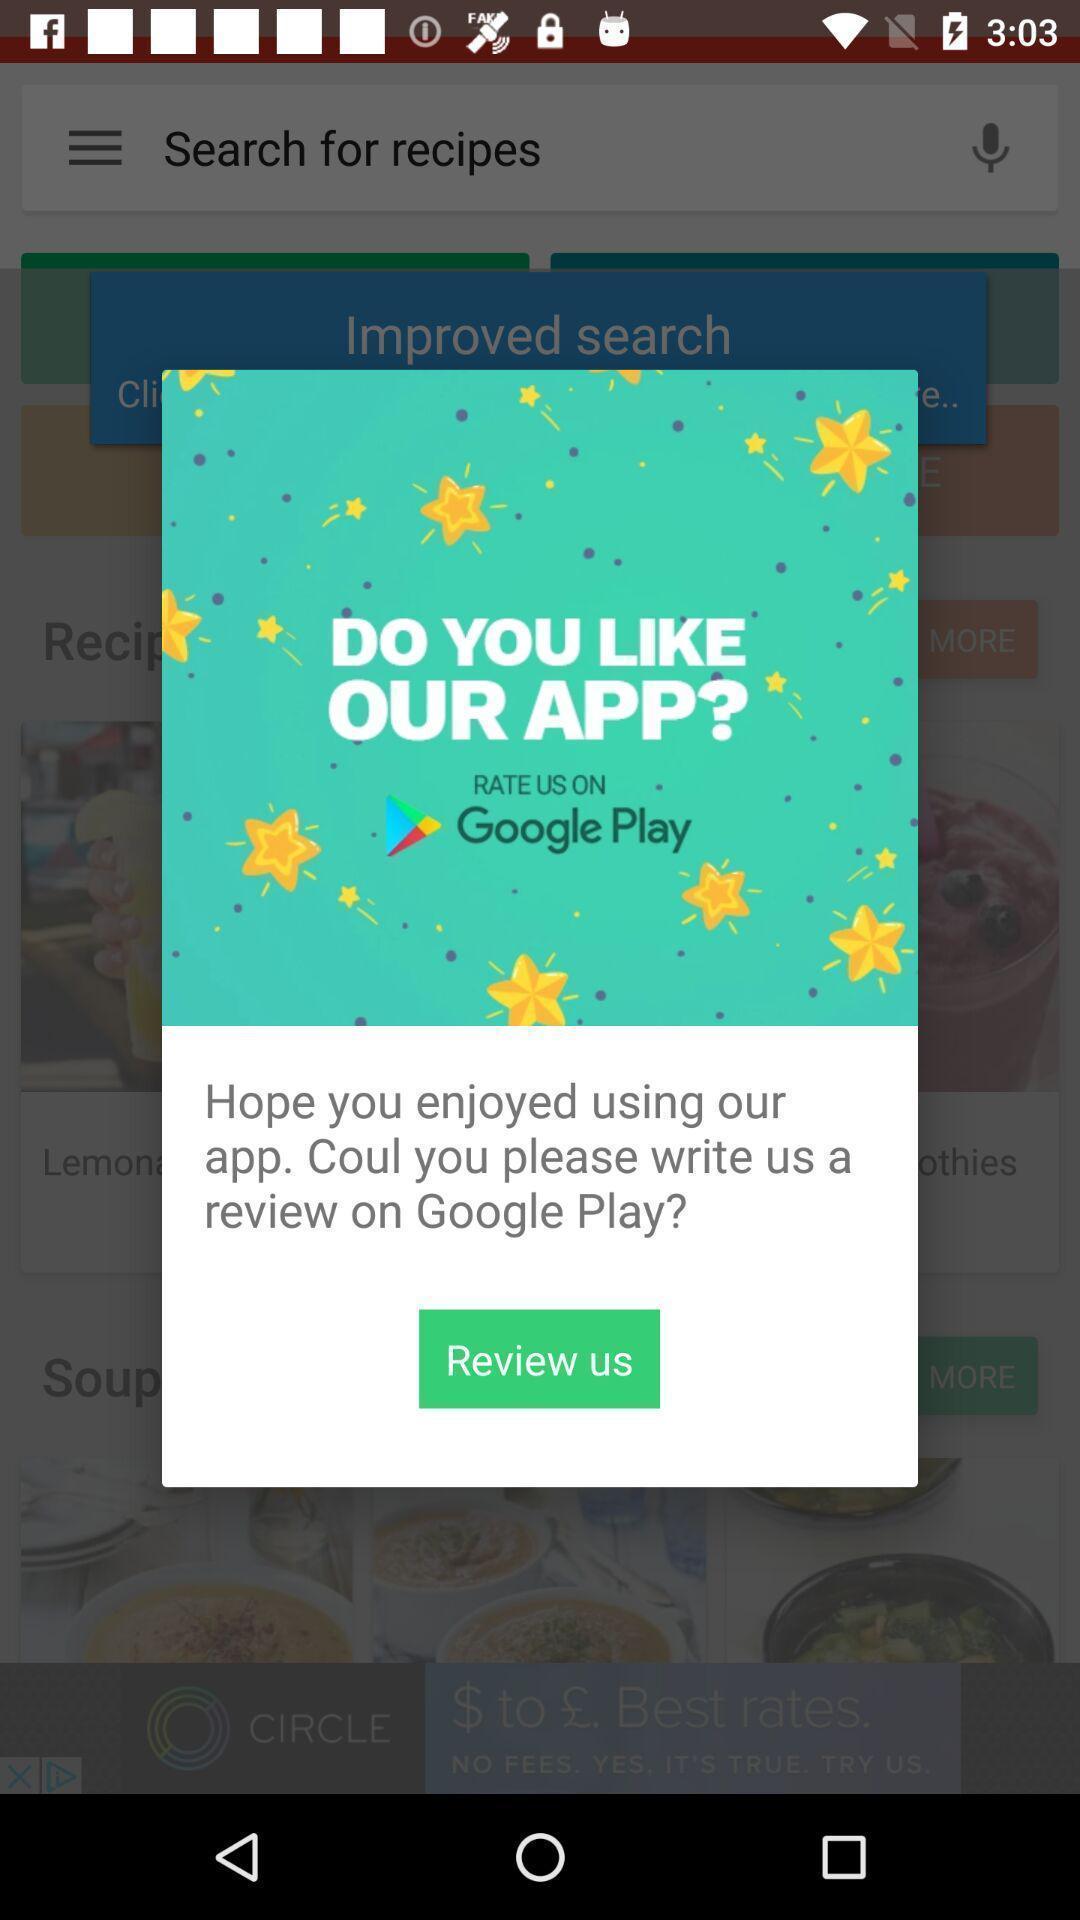Please provide a description for this image. Pop-up message to review about the application. 